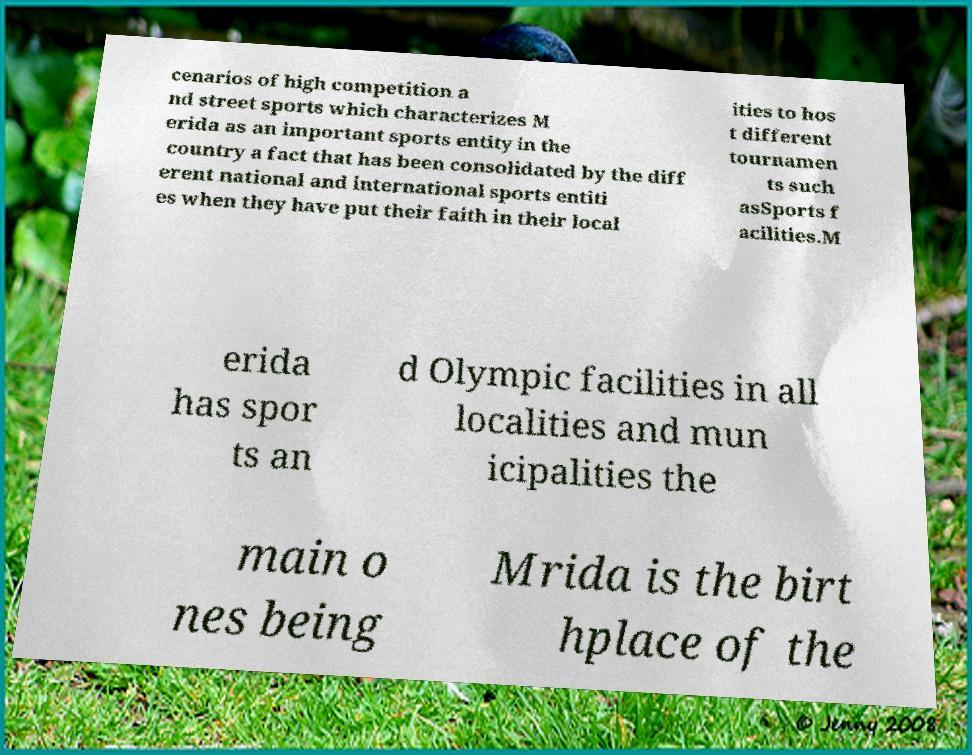Could you assist in decoding the text presented in this image and type it out clearly? cenarios of high competition a nd street sports which characterizes M erida as an important sports entity in the country a fact that has been consolidated by the diff erent national and international sports entiti es when they have put their faith in their local ities to hos t different tournamen ts such asSports f acilities.M erida has spor ts an d Olympic facilities in all localities and mun icipalities the main o nes being Mrida is the birt hplace of the 